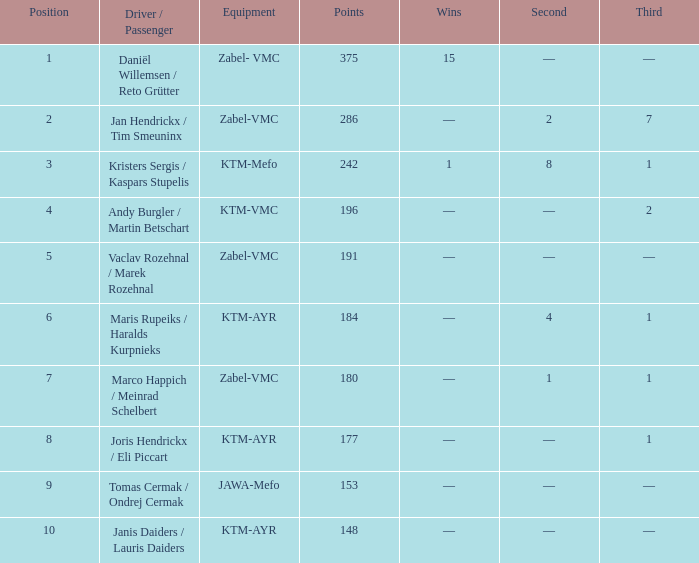What was the highest points when the second was 4? 184.0. 